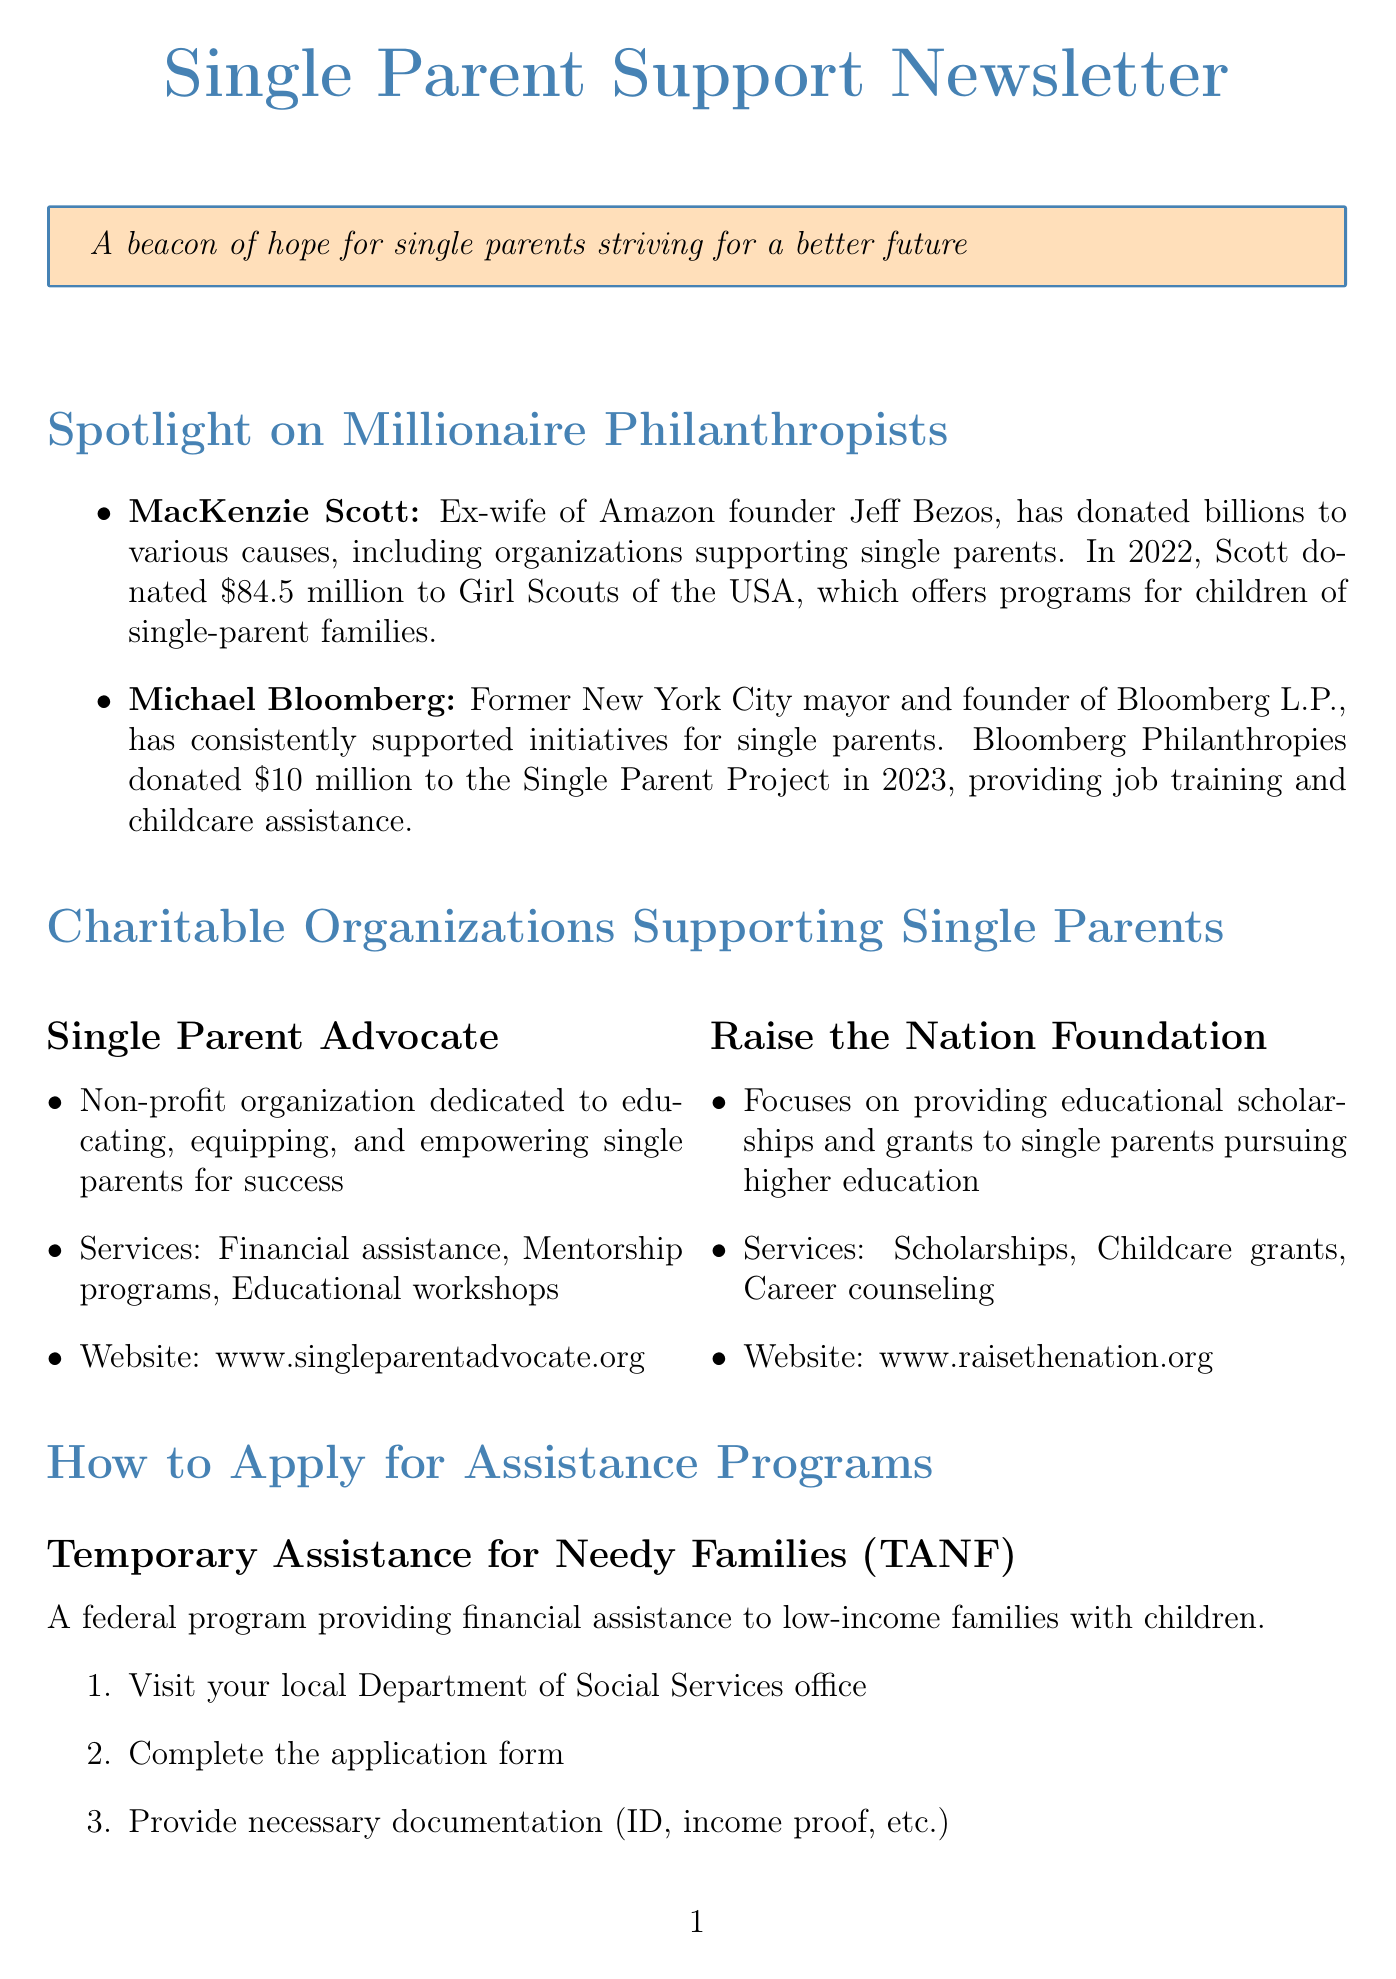What recent donation did MacKenzie Scott make? MacKenzie Scott donated $84.5 million to Girl Scouts of the USA in 2022, which supports single-parent families.
Answer: $84.5 million What services does the Single Parent Advocate offer? The Single Parent Advocate provides financial assistance, mentorship programs, and educational workshops.
Answer: Financial assistance, mentorship programs, educational workshops When is the typical deadline for the Single Parent Scholarship Fund applications? The document states that the deadline is typically March 31st for the fall semester.
Answer: March 31st Who is featured in the success story? The success story is about Sarah Johnson, a single mother who received assistance and completed her nursing degree.
Answer: Sarah Johnson How much did Michael Bloomberg donate to the Single Parent Project in 2023? Michael Bloomberg's donation to the Single Parent Project in 2023 was $10 million.
Answer: $10 million What is the website for the Raise the Nation Foundation? The document provides the website as www.raisethenation.org for further information.
Answer: www.raisethenation.org What is the application process for TANF? The application process for TANF involves visiting the local Department of Social Services office and completing an application form.
Answer: Visit your local Department of Social Services office What is the main goal of the Raise the Nation Foundation? The Raise the Nation Foundation aims to provide educational scholarships and grants to single parents.
Answer: Educational scholarships and grants What is one tip for single parents mentioned in the document? One tip listed in the document is to create a budget and stick to it.
Answer: Create a budget and stick to it 